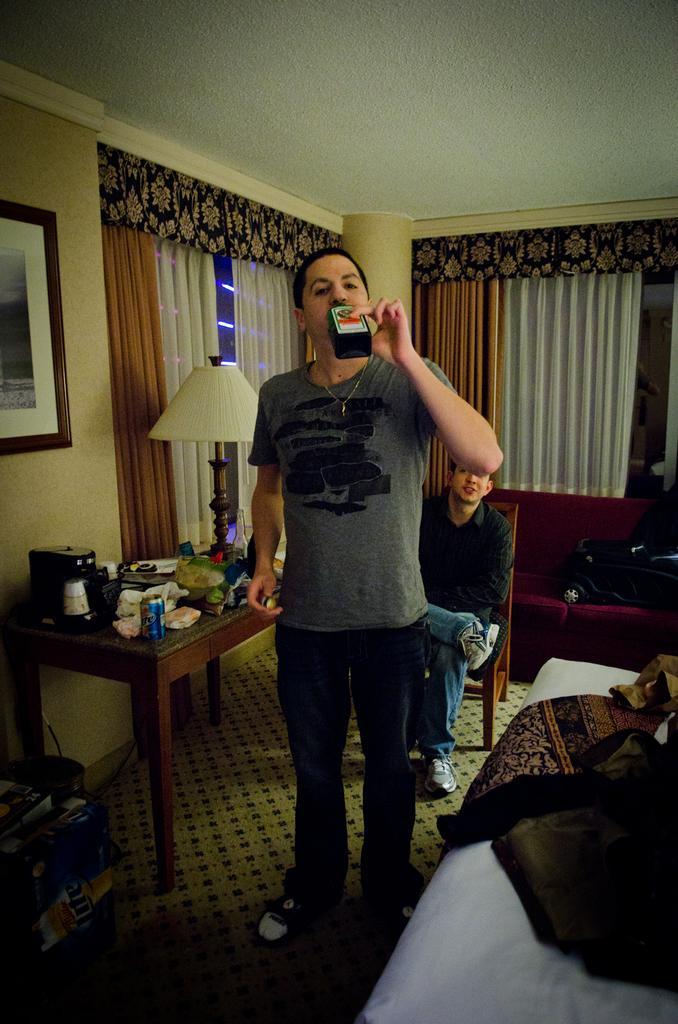Describe this image in one or two sentences. In this image we can see a person holding a bottle. On the bottle we can see a label. Behind the person we can see another person sitting on a chair. Beside the person we can see the few objects on a table and a few objects on a white surface. Behind the persons we can see a wall, windows, curtains and a pillar. At the top we have a roof. On the left side, we can see a frame on the wall and few objects on the floor. 